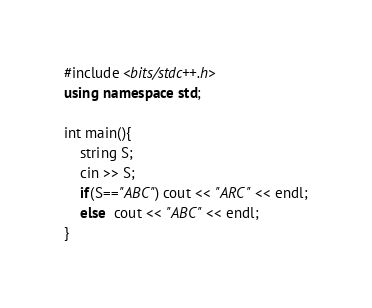<code> <loc_0><loc_0><loc_500><loc_500><_C++_>#include <bits/stdc++.h>
using namespace std;

int main(){
	string S;
	cin >> S;
	if(S=="ABC") cout << "ARC" << endl;
	else  cout << "ABC" << endl;
}

</code> 